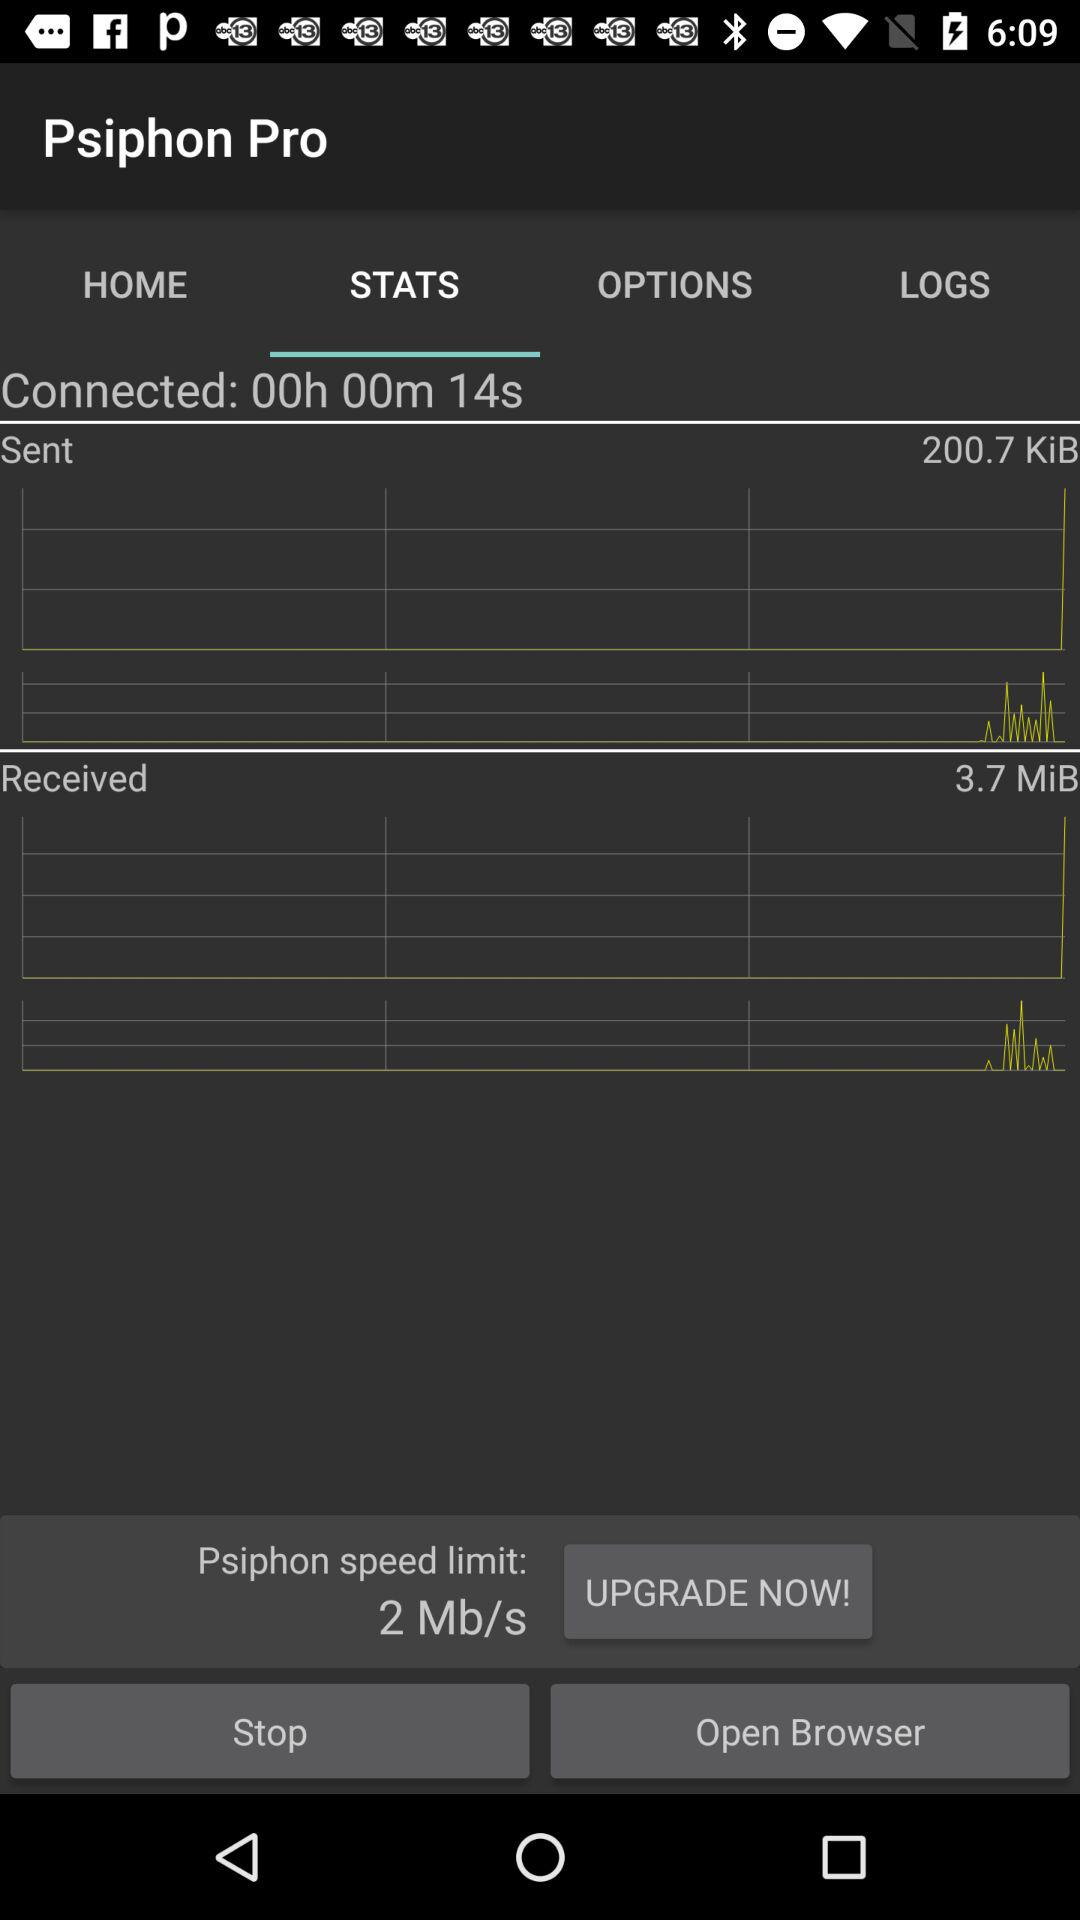How fast is Psiphon?
When the provided information is insufficient, respond with <no answer>. <no answer> 